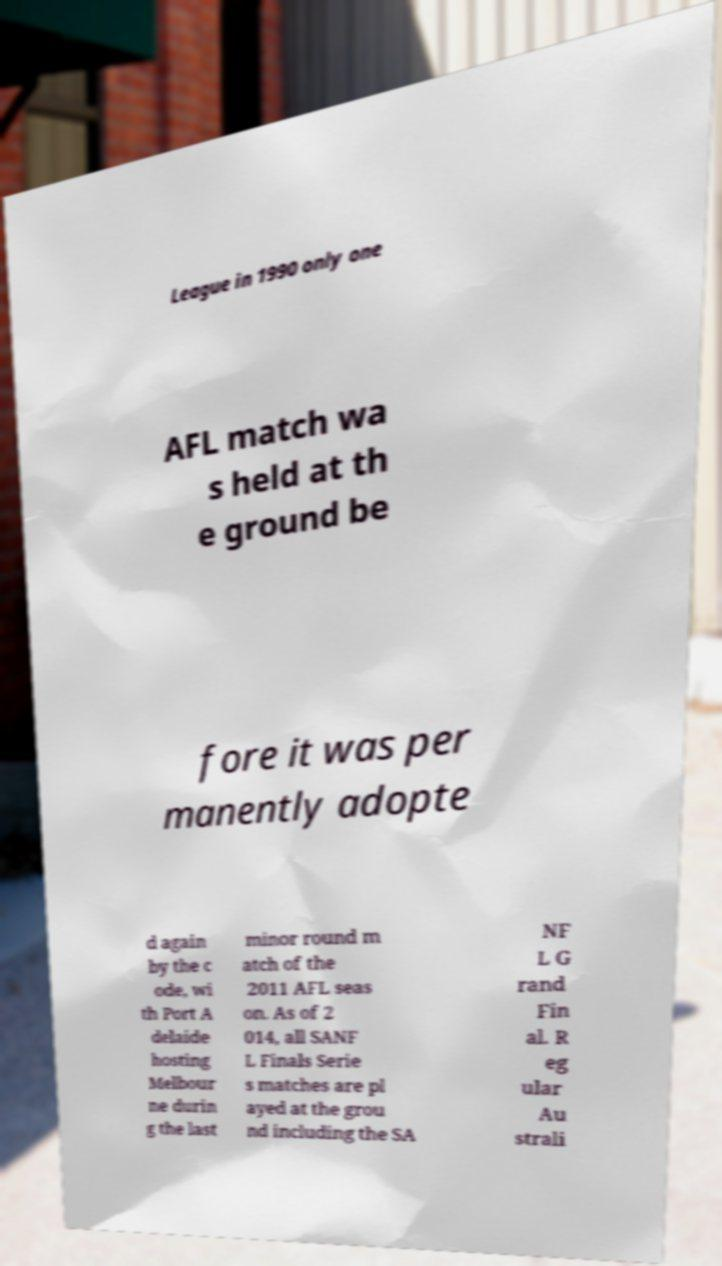Please identify and transcribe the text found in this image. League in 1990 only one AFL match wa s held at th e ground be fore it was per manently adopte d again by the c ode, wi th Port A delaide hosting Melbour ne durin g the last minor round m atch of the 2011 AFL seas on. As of 2 014, all SANF L Finals Serie s matches are pl ayed at the grou nd including the SA NF L G rand Fin al. R eg ular Au strali 